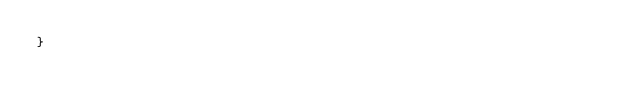Convert code to text. <code><loc_0><loc_0><loc_500><loc_500><_Java_>}
</code> 